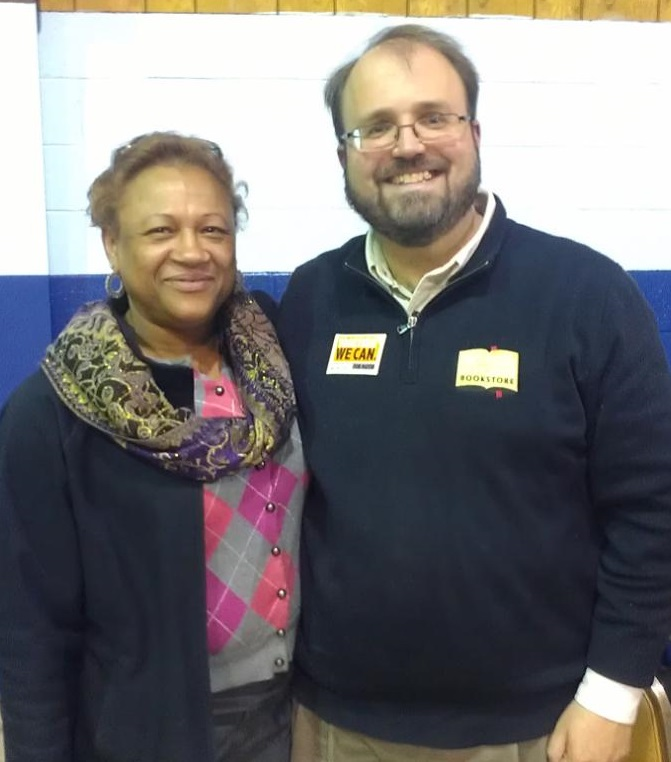What kind of event do you think is taking place here, considering the presence of the two individuals and their attire? The two individuals appear to be dressed in casual yet coordinated attire, which suggests that they might be attending a community event, such as a local gathering or social function. The presence of badges and the friendly demeanor of the individuals further emphasizes that this could be a community initiative or an event where people are coming together to support a cause or celebrate a local accomplishment. Based on their surroundings, can you deduce the possible location of this event? Given the gymnasium-like setting with painted walls and the presence of a wooden ceiling, it is plausible that this event is taking place in a community center, a school gymnasium, or a local recreational hall. Such locations are often used for community gatherings and events due to their open space and accessibility to the members of the community. 